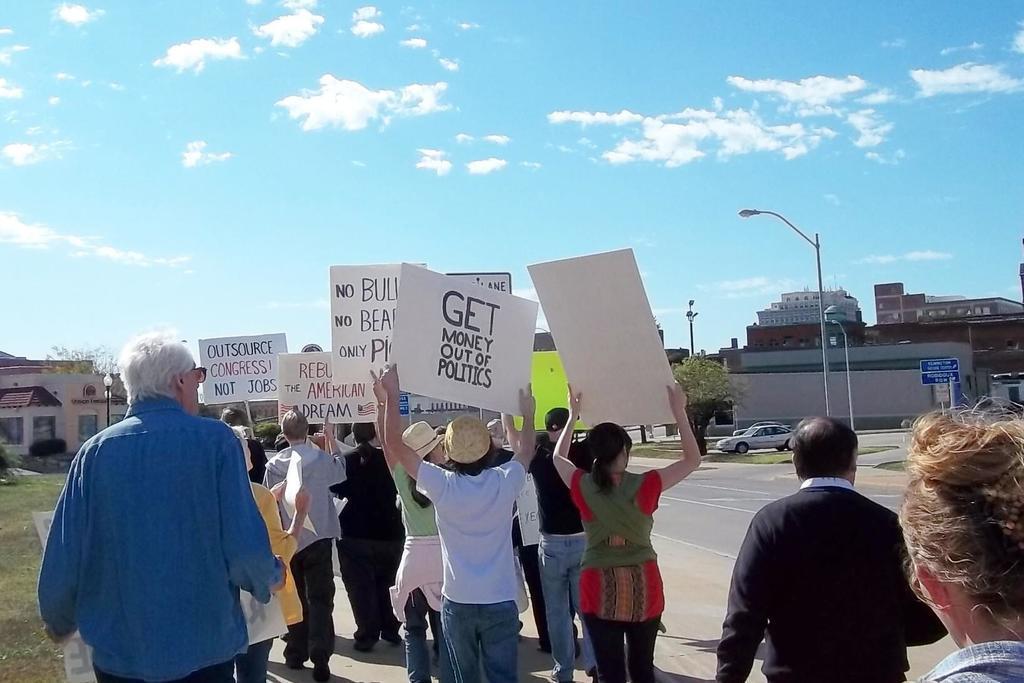How would you summarize this image in a sentence or two? At the left side a man is walking, he wore blue color shirt. In the middle few girls and boys are standing with the placards, on the right side there are houses. At the top it is the blue color sky. 